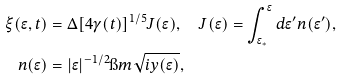<formula> <loc_0><loc_0><loc_500><loc_500>\xi ( \epsilon , t ) & = \Delta [ 4 \gamma ( t ) ] ^ { 1 / 5 } J ( \epsilon ) , \quad J ( \epsilon ) = \int _ { \epsilon _ { \ast } } ^ { \epsilon } d \epsilon ^ { \prime } n ( \epsilon ^ { \prime } ) , \\ n ( \epsilon ) & = | \epsilon | ^ { - 1 / 2 } \i m \sqrt { i y ( \epsilon ) } ,</formula> 